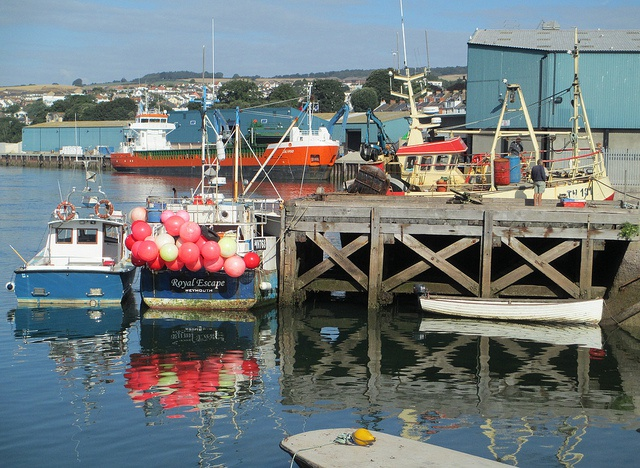Describe the objects in this image and their specific colors. I can see boat in darkgray, ivory, gray, teal, and black tones, boat in darkgray, black, ivory, and salmon tones, boat in darkgray, khaki, tan, and gray tones, and people in darkgray, gray, black, and tan tones in this image. 